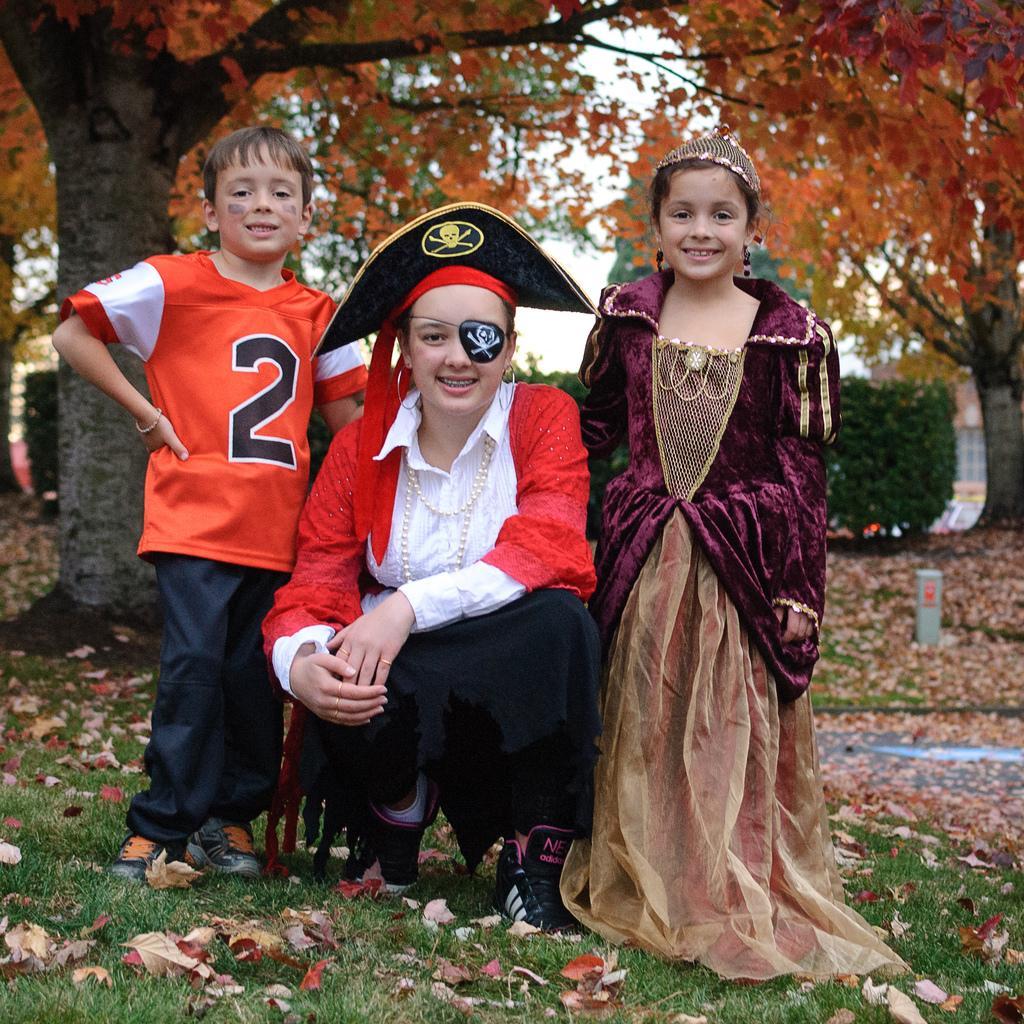Please provide a concise description of this image. In this picture we can see dried leaves, three people on the grass and they are smiling and at the back of them we can see trees, plants, some objects and in the background we can see the sky. 